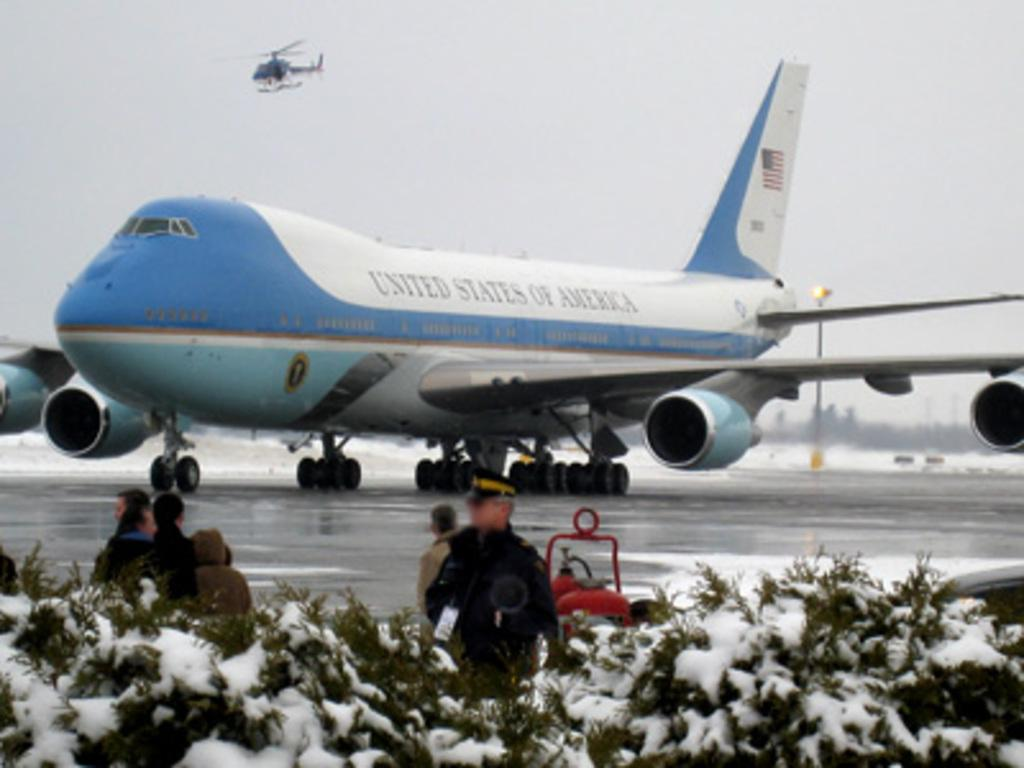<image>
Summarize the visual content of the image. A plane from the United States of America is parked and people are standing in front of it. 